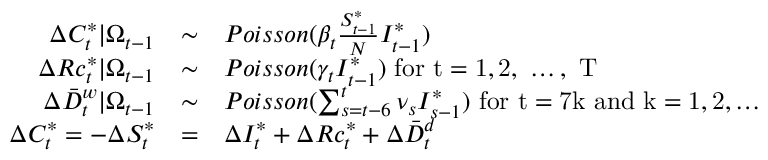<formula> <loc_0><loc_0><loc_500><loc_500>\begin{array} { r c l } { \Delta C _ { t } ^ { * } | \Omega _ { t - 1 } } & { \sim } & { P o i s s o n ( \beta _ { t } \frac { S _ { t - 1 } ^ { * } } { N } I _ { t - 1 } ^ { * } ) } \\ { \Delta R c _ { t } ^ { * } | \Omega _ { t - 1 } } & { \sim } & { P o i s s o n ( \gamma _ { t } I _ { t - 1 } ^ { * } ) f o r t = 1 , 2 , \dots , T } \\ { \Delta \bar { D } _ { t } ^ { w } | \Omega _ { t - 1 } } & { \sim } & { P o i s s o n ( \sum _ { s = t - 6 } ^ { t } \nu _ { s } I _ { s - 1 } ^ { * } ) f o r t = 7 k a n d k = 1 , 2 , \dots } \\ { \Delta C _ { t } ^ { * } = - \Delta S _ { t } ^ { * } } & { = } & { \Delta I _ { t } ^ { * } + \Delta R c _ { t } ^ { * } + \Delta \bar { D } _ { t } ^ { d } } \end{array}</formula> 